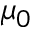<formula> <loc_0><loc_0><loc_500><loc_500>\mu _ { 0 }</formula> 